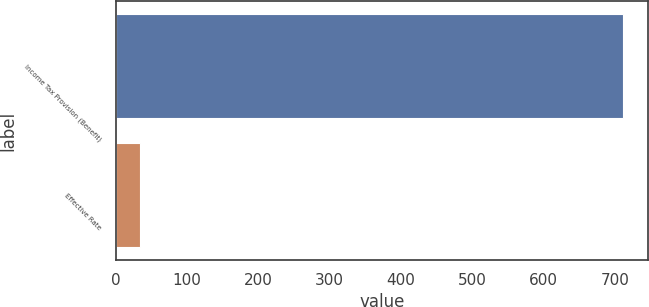Convert chart. <chart><loc_0><loc_0><loc_500><loc_500><bar_chart><fcel>Income Tax Provision (Benefit)<fcel>Effective Rate<nl><fcel>711<fcel>35<nl></chart> 